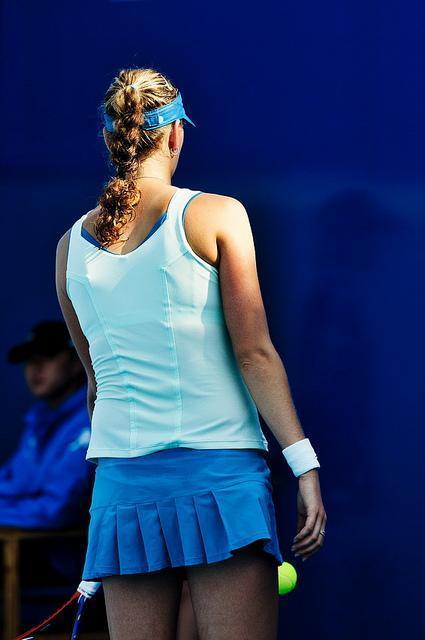How many people are in the photo?
Give a very brief answer. 2. How many chairs are in the photo?
Give a very brief answer. 1. 